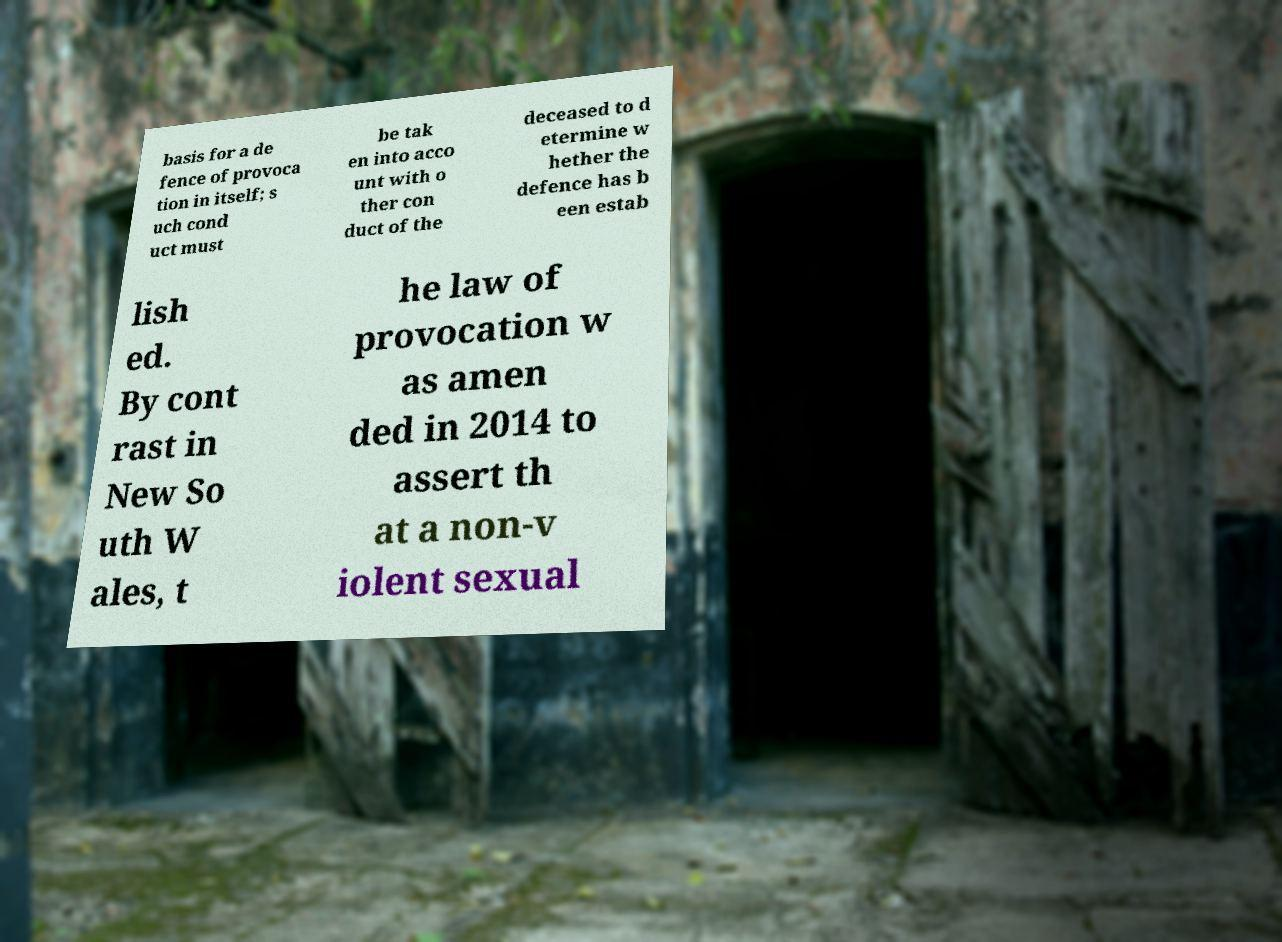Could you extract and type out the text from this image? basis for a de fence of provoca tion in itself; s uch cond uct must be tak en into acco unt with o ther con duct of the deceased to d etermine w hether the defence has b een estab lish ed. By cont rast in New So uth W ales, t he law of provocation w as amen ded in 2014 to assert th at a non-v iolent sexual 